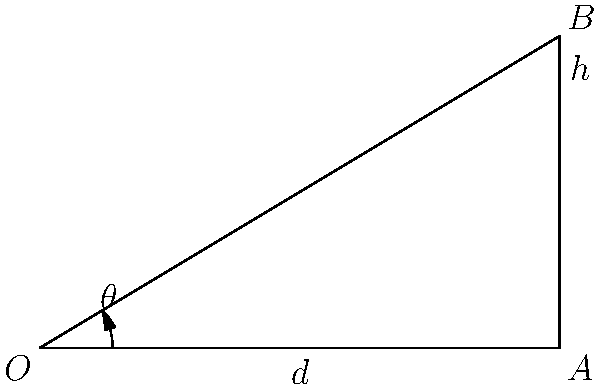As a renewable energy engineer, you're tasked with optimizing the angle of a solar panel for maximum energy capture. The panel is mounted on a rooftop, represented by point $B$ in the diagram. The horizontal distance from the mounting point to the edge of the roof is $d = 5$ meters, and the height of the panel above the roof edge is $h = 3$ meters. What is the optimal angle $\theta$ (in degrees, rounded to the nearest whole number) at which the solar panel should be tilted to be perpendicular to the sun's rays at solar noon? To solve this problem, we'll use trigonometry:

1) In the right triangle OAB:
   - The adjacent side (OA) is the horizontal distance $d = 5$ meters
   - The opposite side (AB) is the height $h = 3$ meters

2) We can find the angle $\theta$ using the arctangent function:

   $\theta = \arctan(\frac{\text{opposite}}{\text{adjacent}}) = \arctan(\frac{h}{d})$

3) Substituting the values:

   $\theta = \arctan(\frac{3}{5})$

4) Calculate:
   $\theta \approx 0.5404$ radians

5) Convert to degrees:
   $\theta \approx 0.5404 \times \frac{180°}{\pi} \approx 30.96°$

6) Rounding to the nearest whole number:
   $\theta \approx 31°$

Therefore, the optimal angle for the solar panel is approximately 31° from the horizontal.
Answer: 31° 